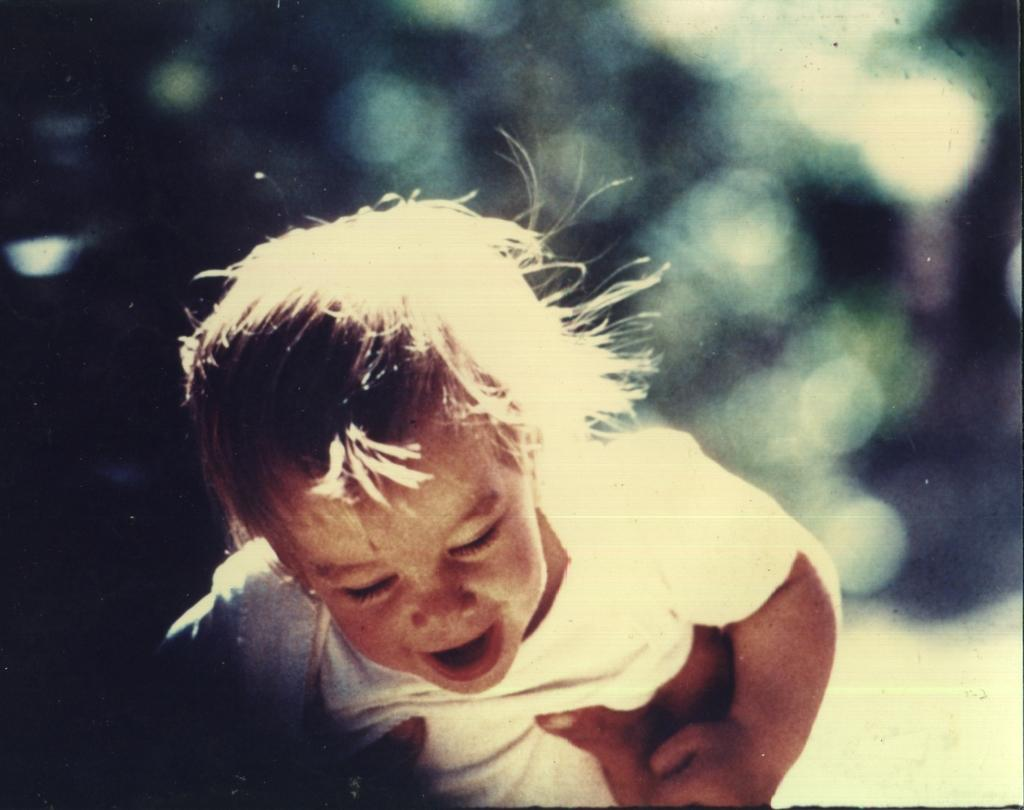What is happening in the image? There is a person holding a child in the image. Can you describe the background of the image? The background of the image is blurry. What type of good-bye message is written on the basket in the image? There is no basket or good-bye message present in the image. What is the person in the image looking at? The provided facts do not mention what the person is looking at, so we cannot definitively answer this question. 